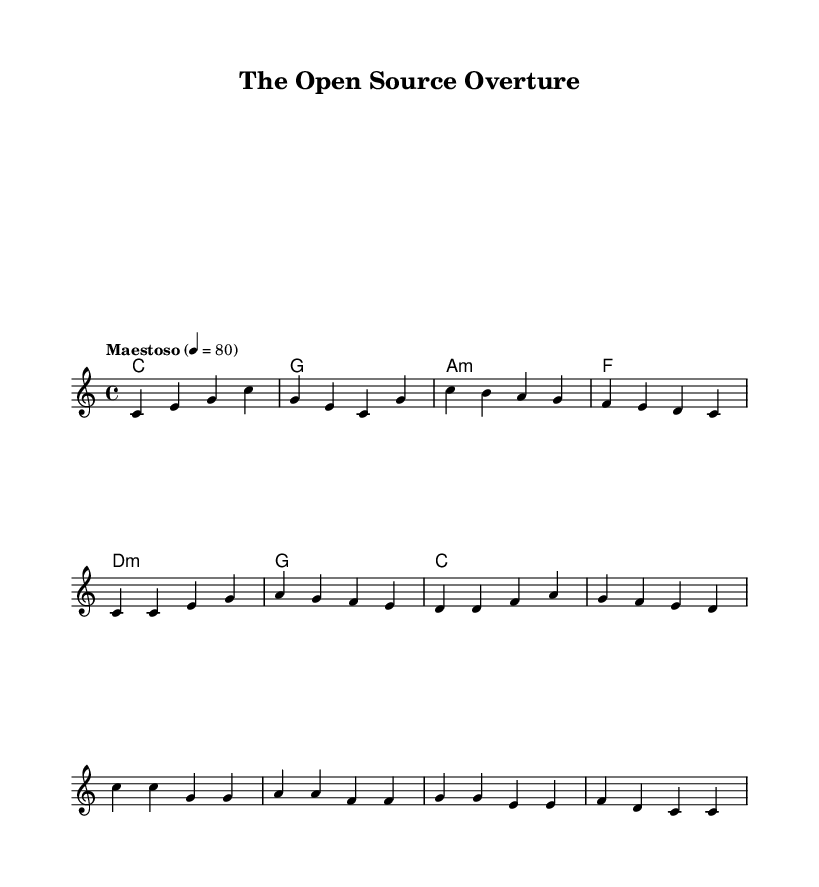What is the key signature of this music? The key signature is indicated at the beginning of the score, and it shows no sharps or flats, which identifies it as C major.
Answer: C major What is the time signature of the piece? The time signature is located at the beginning of the score right after the key signature. It is written as a fraction indicating 4 beats per measure and a quarter note receives one beat.
Answer: 4/4 What is the tempo marking for the piece? The tempo marking is specified in the score and instructs the performer to play the music "Maestoso" at a speed of 80 beats per minute.
Answer: Maestoso 4 = 80 How many measures are in the verse section? By counting the groups of notes and bars in the verse section, we can note that there are 4 measures in the verse before transitioning to the chorus.
Answer: 4 What is the main theme of the chorus lyrics? Analyzing the lyrical content of the chorus, it reflects the concept of open-source collaboration and freedom in software development as expressed through the words used.
Answer: Open source, open minds, collaborating free What instrument is indicated to perform the melody? The indication for the instrument playing the melody is written in the score, specifying the use of a violin to perform the melodic line.
Answer: Violin How many chords are present in the harmony section? Looking at the harmony section, we can see a set of chord symbols aligning with the melody, which shows there are a total of 6 chords used throughout.
Answer: 6 